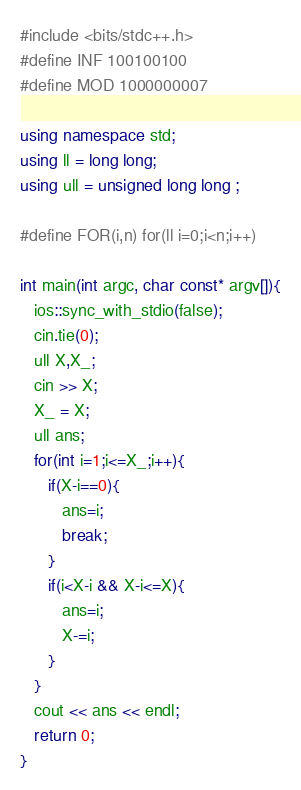Convert code to text. <code><loc_0><loc_0><loc_500><loc_500><_C++_>#include <bits/stdc++.h>
#define INF 100100100
#define MOD 1000000007

using namespace std;
using ll = long long;
using ull = unsigned long long ;

#define FOR(i,n) for(ll i=0;i<n;i++)

int main(int argc, char const* argv[]){
   ios::sync_with_stdio(false);
   cin.tie(0); 
   ull X,X_;
   cin >> X;
   X_ = X;
   ull ans;
   for(int i=1;i<=X_;i++){
      if(X-i==0){
         ans=i;
         break;
      }
      if(i<X-i && X-i<=X){
         ans=i;
         X-=i;
      }
   }
   cout << ans << endl;
   return 0;
}
</code> 